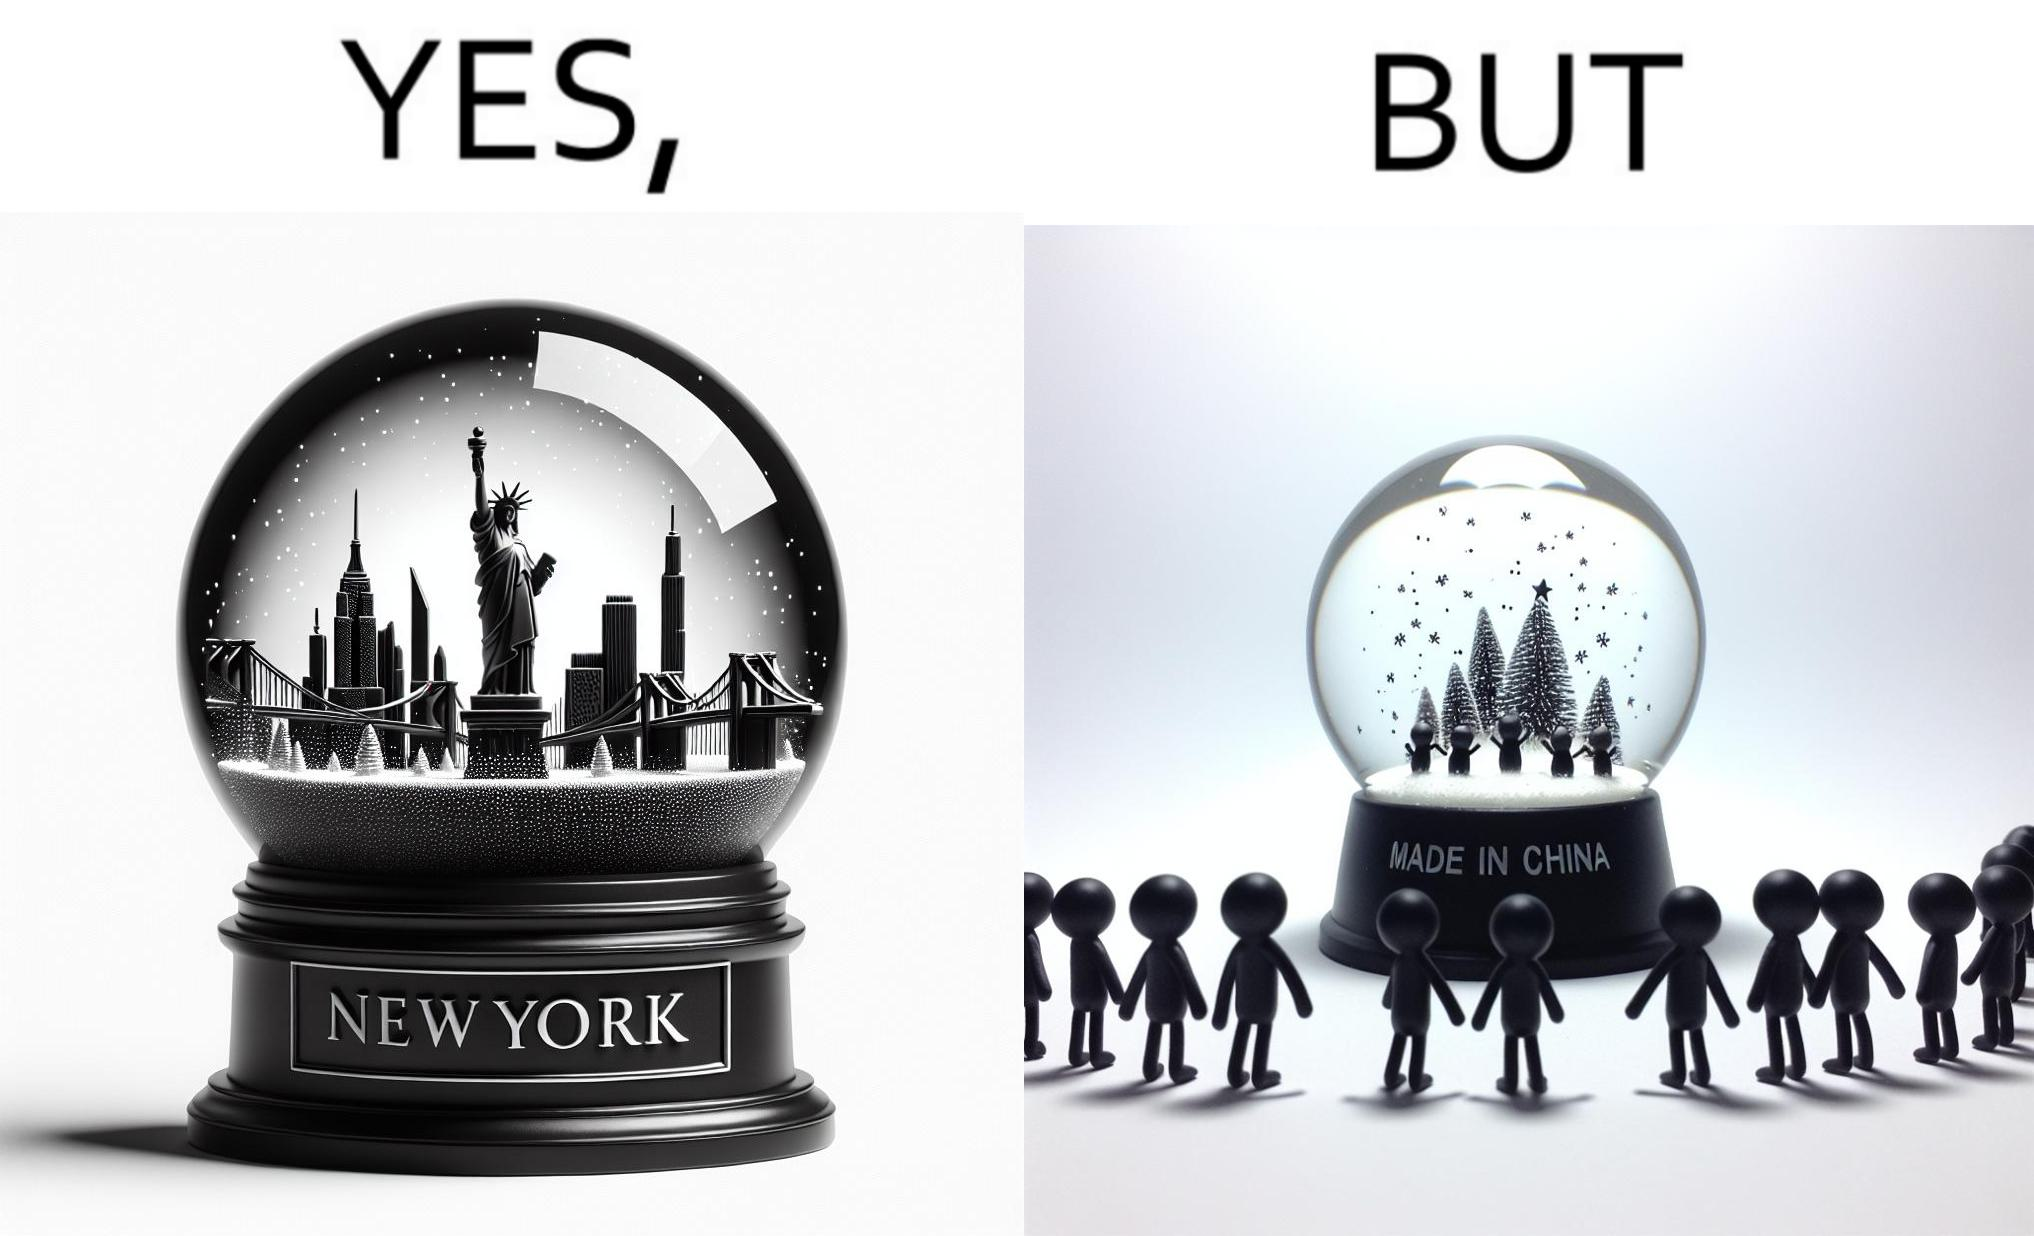Compare the left and right sides of this image. In the left part of the image: A snowglobe that says 'New York' In the right part of the image: Made in china' label on the snowglobe 